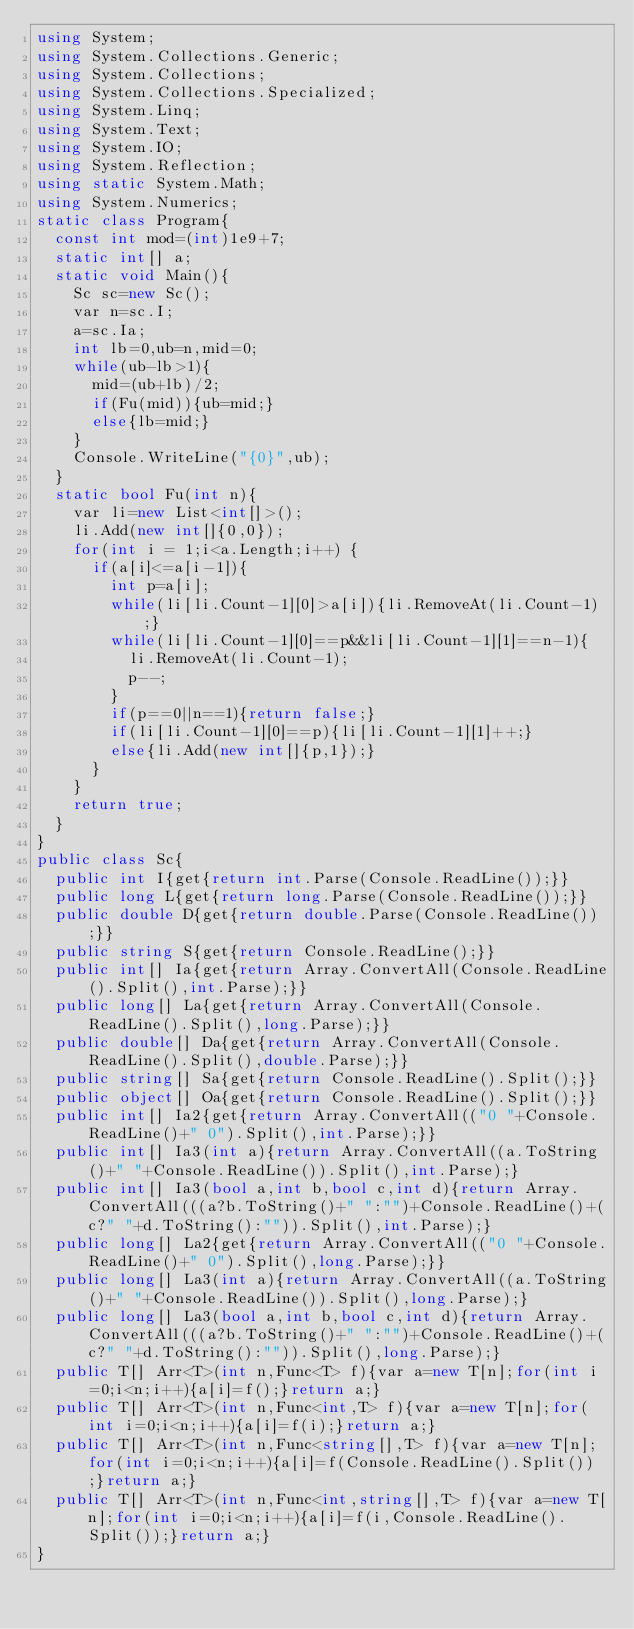<code> <loc_0><loc_0><loc_500><loc_500><_C#_>using System;
using System.Collections.Generic;
using System.Collections;
using System.Collections.Specialized;
using System.Linq;
using System.Text;
using System.IO;
using System.Reflection;
using static System.Math;
using System.Numerics;
static class Program{
	const int mod=(int)1e9+7;
	static int[] a;
	static void Main(){
		Sc sc=new Sc();
		var n=sc.I;
		a=sc.Ia;
		int lb=0,ub=n,mid=0;
		while(ub-lb>1){
			mid=(ub+lb)/2;
			if(Fu(mid)){ub=mid;}
			else{lb=mid;}
		}
		Console.WriteLine("{0}",ub);
	}
	static bool Fu(int n){
		var li=new List<int[]>();
		li.Add(new int[]{0,0});
		for(int i = 1;i<a.Length;i++) {
			if(a[i]<=a[i-1]){
				int p=a[i];
				while(li[li.Count-1][0]>a[i]){li.RemoveAt(li.Count-1);}
				while(li[li.Count-1][0]==p&&li[li.Count-1][1]==n-1){
					li.RemoveAt(li.Count-1);
					p--;
				}
				if(p==0||n==1){return false;}
				if(li[li.Count-1][0]==p){li[li.Count-1][1]++;}
				else{li.Add(new int[]{p,1});}
			}
		}
		return true;
	}
}
public class Sc{
	public int I{get{return int.Parse(Console.ReadLine());}}
	public long L{get{return long.Parse(Console.ReadLine());}}
	public double D{get{return double.Parse(Console.ReadLine());}}
	public string S{get{return Console.ReadLine();}}
	public int[] Ia{get{return Array.ConvertAll(Console.ReadLine().Split(),int.Parse);}}
	public long[] La{get{return Array.ConvertAll(Console.ReadLine().Split(),long.Parse);}}
	public double[] Da{get{return Array.ConvertAll(Console.ReadLine().Split(),double.Parse);}}
	public string[] Sa{get{return Console.ReadLine().Split();}}
	public object[] Oa{get{return Console.ReadLine().Split();}}
	public int[] Ia2{get{return Array.ConvertAll(("0 "+Console.ReadLine()+" 0").Split(),int.Parse);}}
	public int[] Ia3(int a){return Array.ConvertAll((a.ToString()+" "+Console.ReadLine()).Split(),int.Parse);}
	public int[] Ia3(bool a,int b,bool c,int d){return Array.ConvertAll(((a?b.ToString()+" ":"")+Console.ReadLine()+(c?" "+d.ToString():"")).Split(),int.Parse);}
	public long[] La2{get{return Array.ConvertAll(("0 "+Console.ReadLine()+" 0").Split(),long.Parse);}}
	public long[] La3(int a){return Array.ConvertAll((a.ToString()+" "+Console.ReadLine()).Split(),long.Parse);}
	public long[] La3(bool a,int b,bool c,int d){return Array.ConvertAll(((a?b.ToString()+" ":"")+Console.ReadLine()+(c?" "+d.ToString():"")).Split(),long.Parse);}
	public T[] Arr<T>(int n,Func<T> f){var a=new T[n];for(int i=0;i<n;i++){a[i]=f();}return a;}
	public T[] Arr<T>(int n,Func<int,T> f){var a=new T[n];for(int i=0;i<n;i++){a[i]=f(i);}return a;}
	public T[] Arr<T>(int n,Func<string[],T> f){var a=new T[n];for(int i=0;i<n;i++){a[i]=f(Console.ReadLine().Split());}return a;}
	public T[] Arr<T>(int n,Func<int,string[],T> f){var a=new T[n];for(int i=0;i<n;i++){a[i]=f(i,Console.ReadLine().Split());}return a;}
}</code> 